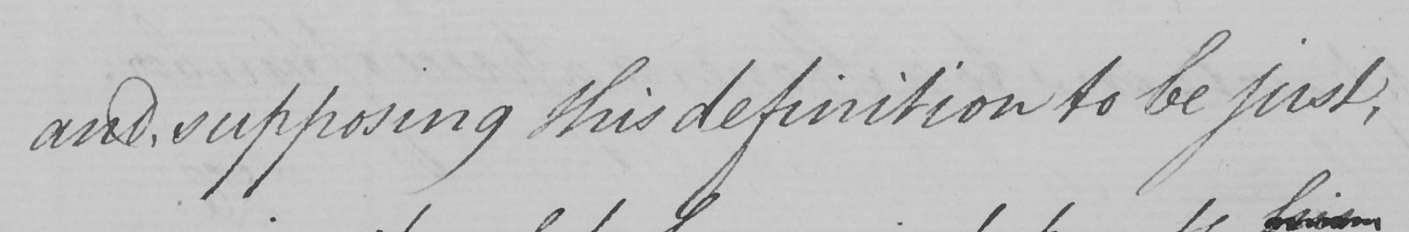Can you tell me what this handwritten text says? and , supposing this definition to be just , 